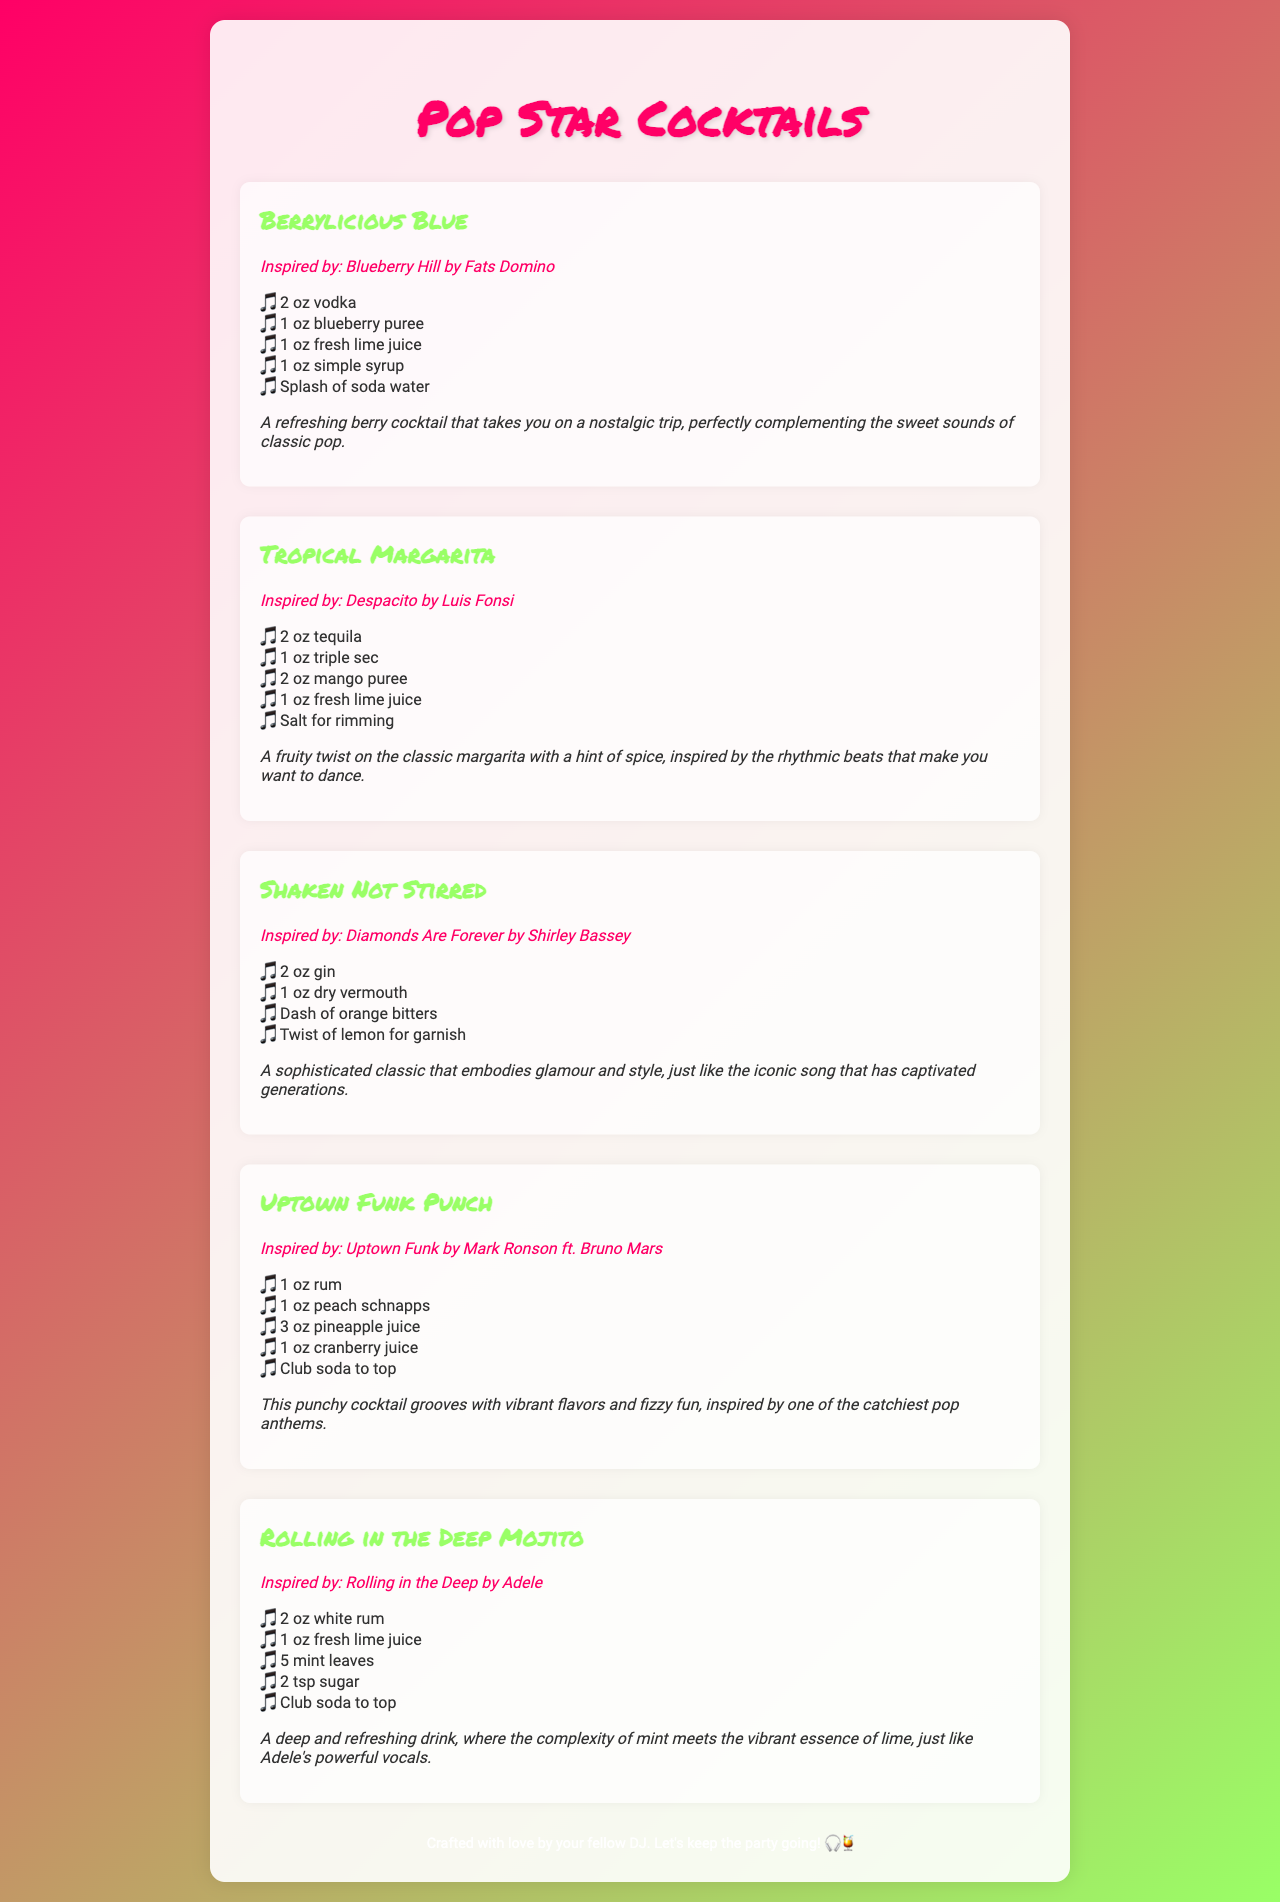What is the first cocktail listed? The first cocktail in the menu is the one at the top of the list.
Answer: Berrylicious Blue How many ounces of tequila are in the Tropical Margarita? The Tropical Margarita cocktail includes 2 ounces of tequila as one of its ingredients.
Answer: 2 oz Which cocktail is inspired by a song from Adele? The document includes a cocktail that specifically mentions Adele and her song in its description.
Answer: Rolling in the Deep Mojito What type of cocktail is 'Shaken Not Stirred'? The type of this cocktail can be found in the title, which often reflects the style or main spirit used.
Answer: Gin cocktail List one ingredient in the Uptown Funk Punch. Each cocktail includes a list of ingredients; one can be selected from the Uptown Funk Punch.
Answer: Rum 